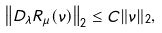<formula> <loc_0><loc_0><loc_500><loc_500>\left \| D _ { \lambda } R _ { \mu } ( \nu ) \right \| _ { 2 } \leq C \| \nu \| _ { 2 } ,</formula> 